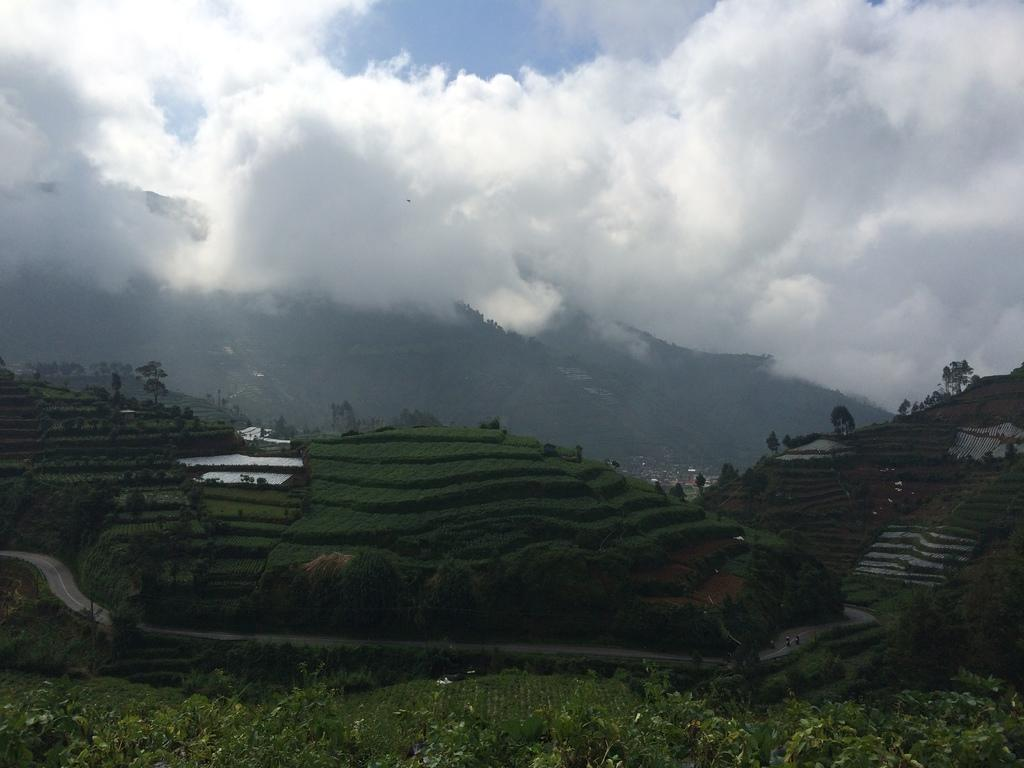What type of vegetation can be seen in the image? There are plants and grass in the image. What is visible in the background of the image? There are trees in the background of the image. How would you describe the sky in the image? The sky is cloudy in the image. How many oranges can be seen hanging from the trees in the image? There are no oranges present in the image; it features plants, grass, trees, and a cloudy sky. Is there a deer visible in the image? There is no deer present in the image. 